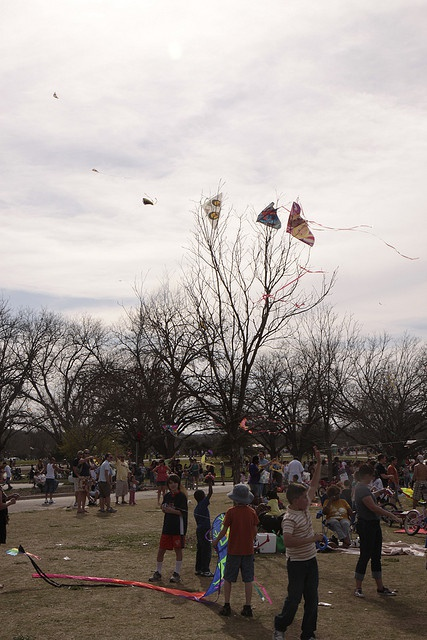Describe the objects in this image and their specific colors. I can see people in white, black, and gray tones, people in white, black, and gray tones, people in white, black, and gray tones, people in white, black, maroon, and gray tones, and kite in white, black, maroon, and gray tones in this image. 